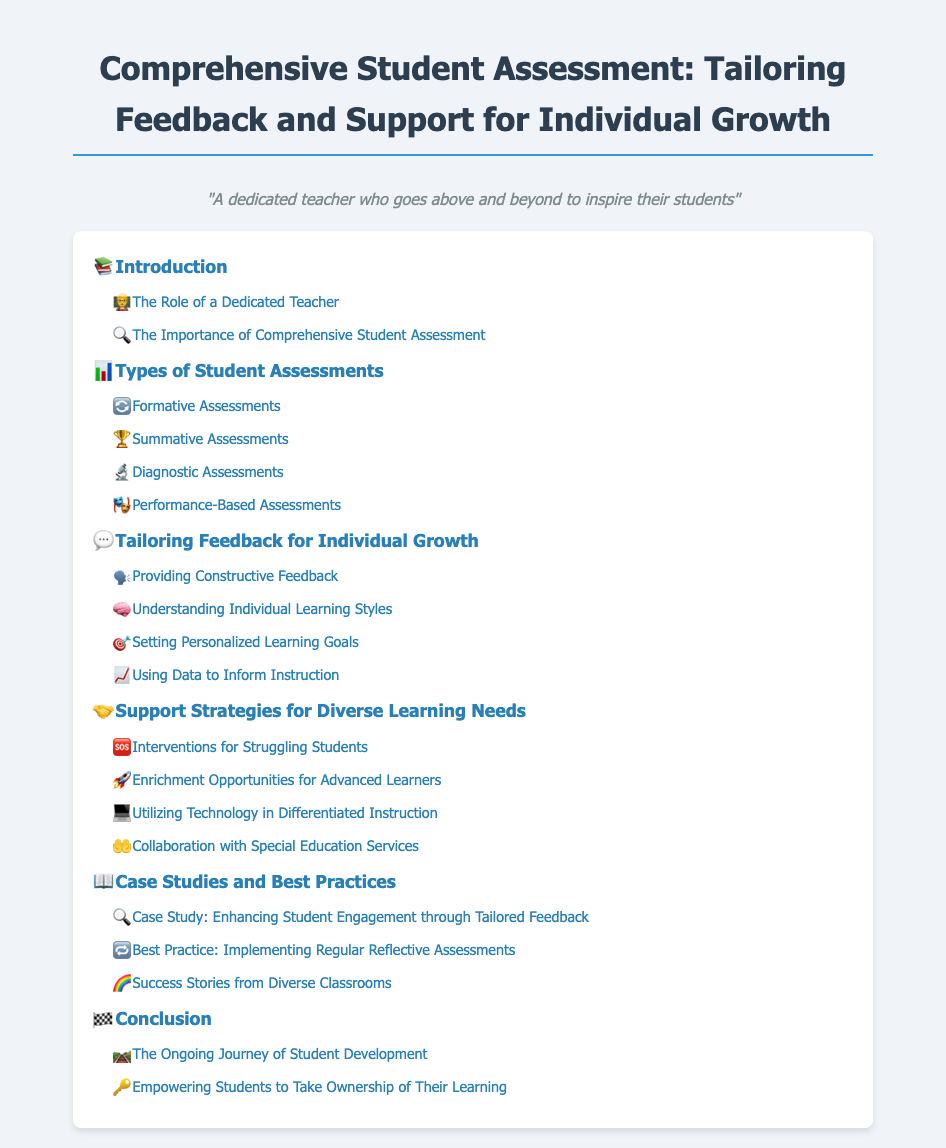What is the title of the document? The title of the document is mentioned at the top of the page.
Answer: Comprehensive Student Assessment: Tailoring Feedback and Support for Individual Growth What section focuses on teacher's roles? The section about the teacher's roles is a level-2 item under the introduction.
Answer: The Role of a Dedicated Teacher How many types of student assessments are listed? The document lists four types of student assessments under the respective heading.
Answer: Four What icon represents feedback for individual growth? The icon associated with tailoring feedback is unique to that section in the table of contents.
Answer: 💬 What is a key strategy for struggling students? The key strategy is outlined in the section for support strategies and is a level-2 item.
Answer: Interventions for Struggling Students Which section discusses success stories? The specific section dedicated to success stories is listed under the case studies heading.
Answer: Success Stories from Diverse Classrooms What is the last section in the document? The last section is provided at the end of the table of contents, indicating its importance.
Answer: Conclusion How many case studies are mentioned? The document mentions three specific case studies under the case studies heading.
Answer: Three 